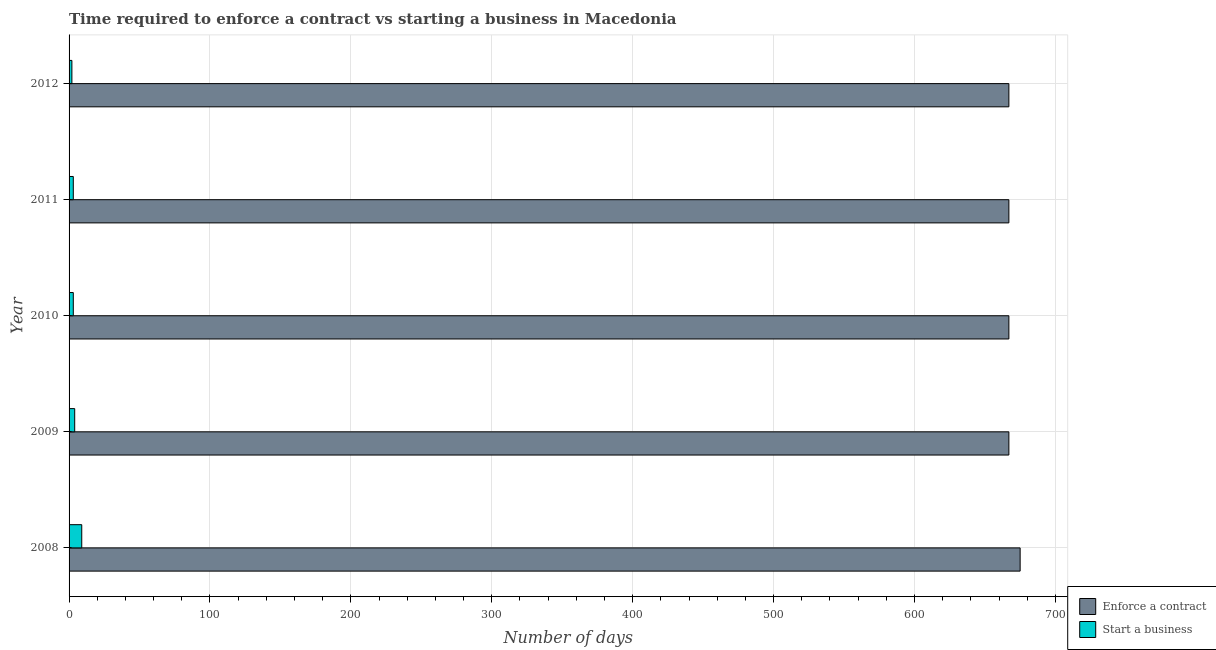How many different coloured bars are there?
Provide a succinct answer. 2. How many groups of bars are there?
Offer a terse response. 5. Are the number of bars per tick equal to the number of legend labels?
Ensure brevity in your answer.  Yes. Are the number of bars on each tick of the Y-axis equal?
Your answer should be very brief. Yes. In how many cases, is the number of bars for a given year not equal to the number of legend labels?
Your answer should be very brief. 0. What is the number of days to enforece a contract in 2009?
Offer a very short reply. 667. Across all years, what is the maximum number of days to start a business?
Your response must be concise. 9. Across all years, what is the minimum number of days to start a business?
Offer a terse response. 2. In which year was the number of days to enforece a contract minimum?
Provide a short and direct response. 2009. What is the total number of days to start a business in the graph?
Offer a terse response. 21. What is the difference between the number of days to start a business in 2009 and that in 2011?
Give a very brief answer. 1. What is the difference between the number of days to enforece a contract in 2008 and the number of days to start a business in 2011?
Your answer should be very brief. 672. In the year 2008, what is the difference between the number of days to enforece a contract and number of days to start a business?
Provide a succinct answer. 666. In how many years, is the number of days to start a business greater than 480 days?
Your response must be concise. 0. Is the number of days to enforece a contract in 2009 less than that in 2012?
Ensure brevity in your answer.  No. Is the difference between the number of days to start a business in 2010 and 2012 greater than the difference between the number of days to enforece a contract in 2010 and 2012?
Offer a terse response. Yes. What is the difference between the highest and the second highest number of days to start a business?
Your answer should be very brief. 5. What is the difference between the highest and the lowest number of days to start a business?
Provide a succinct answer. 7. In how many years, is the number of days to enforece a contract greater than the average number of days to enforece a contract taken over all years?
Give a very brief answer. 1. What does the 2nd bar from the top in 2010 represents?
Offer a very short reply. Enforce a contract. What does the 1st bar from the bottom in 2010 represents?
Ensure brevity in your answer.  Enforce a contract. How many bars are there?
Provide a short and direct response. 10. What is the difference between two consecutive major ticks on the X-axis?
Keep it short and to the point. 100. Does the graph contain any zero values?
Provide a succinct answer. No. Where does the legend appear in the graph?
Provide a succinct answer. Bottom right. What is the title of the graph?
Make the answer very short. Time required to enforce a contract vs starting a business in Macedonia. What is the label or title of the X-axis?
Offer a very short reply. Number of days. What is the label or title of the Y-axis?
Ensure brevity in your answer.  Year. What is the Number of days of Enforce a contract in 2008?
Keep it short and to the point. 675. What is the Number of days of Start a business in 2008?
Offer a terse response. 9. What is the Number of days of Enforce a contract in 2009?
Ensure brevity in your answer.  667. What is the Number of days of Start a business in 2009?
Your answer should be compact. 4. What is the Number of days in Enforce a contract in 2010?
Your response must be concise. 667. What is the Number of days of Enforce a contract in 2011?
Keep it short and to the point. 667. What is the Number of days in Start a business in 2011?
Your answer should be compact. 3. What is the Number of days of Enforce a contract in 2012?
Give a very brief answer. 667. What is the Number of days of Start a business in 2012?
Provide a short and direct response. 2. Across all years, what is the maximum Number of days of Enforce a contract?
Make the answer very short. 675. Across all years, what is the maximum Number of days of Start a business?
Provide a short and direct response. 9. Across all years, what is the minimum Number of days in Enforce a contract?
Give a very brief answer. 667. What is the total Number of days of Enforce a contract in the graph?
Offer a very short reply. 3343. What is the total Number of days in Start a business in the graph?
Your answer should be compact. 21. What is the difference between the Number of days of Enforce a contract in 2008 and that in 2009?
Provide a short and direct response. 8. What is the difference between the Number of days of Start a business in 2008 and that in 2009?
Provide a short and direct response. 5. What is the difference between the Number of days of Enforce a contract in 2008 and that in 2010?
Offer a very short reply. 8. What is the difference between the Number of days in Start a business in 2008 and that in 2010?
Offer a terse response. 6. What is the difference between the Number of days of Enforce a contract in 2008 and that in 2011?
Offer a terse response. 8. What is the difference between the Number of days in Enforce a contract in 2009 and that in 2011?
Your answer should be compact. 0. What is the difference between the Number of days of Start a business in 2009 and that in 2012?
Your answer should be compact. 2. What is the difference between the Number of days in Enforce a contract in 2010 and that in 2011?
Keep it short and to the point. 0. What is the difference between the Number of days of Start a business in 2011 and that in 2012?
Provide a short and direct response. 1. What is the difference between the Number of days of Enforce a contract in 2008 and the Number of days of Start a business in 2009?
Keep it short and to the point. 671. What is the difference between the Number of days in Enforce a contract in 2008 and the Number of days in Start a business in 2010?
Give a very brief answer. 672. What is the difference between the Number of days of Enforce a contract in 2008 and the Number of days of Start a business in 2011?
Provide a short and direct response. 672. What is the difference between the Number of days in Enforce a contract in 2008 and the Number of days in Start a business in 2012?
Your answer should be very brief. 673. What is the difference between the Number of days of Enforce a contract in 2009 and the Number of days of Start a business in 2010?
Ensure brevity in your answer.  664. What is the difference between the Number of days of Enforce a contract in 2009 and the Number of days of Start a business in 2011?
Your answer should be very brief. 664. What is the difference between the Number of days of Enforce a contract in 2009 and the Number of days of Start a business in 2012?
Give a very brief answer. 665. What is the difference between the Number of days of Enforce a contract in 2010 and the Number of days of Start a business in 2011?
Your answer should be very brief. 664. What is the difference between the Number of days of Enforce a contract in 2010 and the Number of days of Start a business in 2012?
Your answer should be compact. 665. What is the difference between the Number of days in Enforce a contract in 2011 and the Number of days in Start a business in 2012?
Offer a very short reply. 665. What is the average Number of days of Enforce a contract per year?
Provide a succinct answer. 668.6. What is the average Number of days of Start a business per year?
Your response must be concise. 4.2. In the year 2008, what is the difference between the Number of days of Enforce a contract and Number of days of Start a business?
Your response must be concise. 666. In the year 2009, what is the difference between the Number of days in Enforce a contract and Number of days in Start a business?
Provide a short and direct response. 663. In the year 2010, what is the difference between the Number of days of Enforce a contract and Number of days of Start a business?
Provide a short and direct response. 664. In the year 2011, what is the difference between the Number of days in Enforce a contract and Number of days in Start a business?
Provide a short and direct response. 664. In the year 2012, what is the difference between the Number of days in Enforce a contract and Number of days in Start a business?
Your answer should be compact. 665. What is the ratio of the Number of days in Enforce a contract in 2008 to that in 2009?
Provide a short and direct response. 1.01. What is the ratio of the Number of days of Start a business in 2008 to that in 2009?
Keep it short and to the point. 2.25. What is the ratio of the Number of days of Enforce a contract in 2008 to that in 2010?
Your answer should be very brief. 1.01. What is the ratio of the Number of days in Start a business in 2008 to that in 2010?
Provide a short and direct response. 3. What is the ratio of the Number of days of Enforce a contract in 2008 to that in 2011?
Provide a short and direct response. 1.01. What is the ratio of the Number of days of Enforce a contract in 2008 to that in 2012?
Your response must be concise. 1.01. What is the ratio of the Number of days of Start a business in 2008 to that in 2012?
Give a very brief answer. 4.5. What is the ratio of the Number of days of Enforce a contract in 2009 to that in 2010?
Make the answer very short. 1. What is the ratio of the Number of days of Start a business in 2009 to that in 2010?
Your response must be concise. 1.33. What is the ratio of the Number of days in Start a business in 2009 to that in 2011?
Your response must be concise. 1.33. What is the ratio of the Number of days in Enforce a contract in 2009 to that in 2012?
Your answer should be very brief. 1. What is the ratio of the Number of days of Enforce a contract in 2010 to that in 2011?
Give a very brief answer. 1. What is the ratio of the Number of days in Start a business in 2010 to that in 2011?
Provide a succinct answer. 1. What is the ratio of the Number of days of Enforce a contract in 2010 to that in 2012?
Offer a terse response. 1. What is the difference between the highest and the lowest Number of days of Enforce a contract?
Give a very brief answer. 8. 